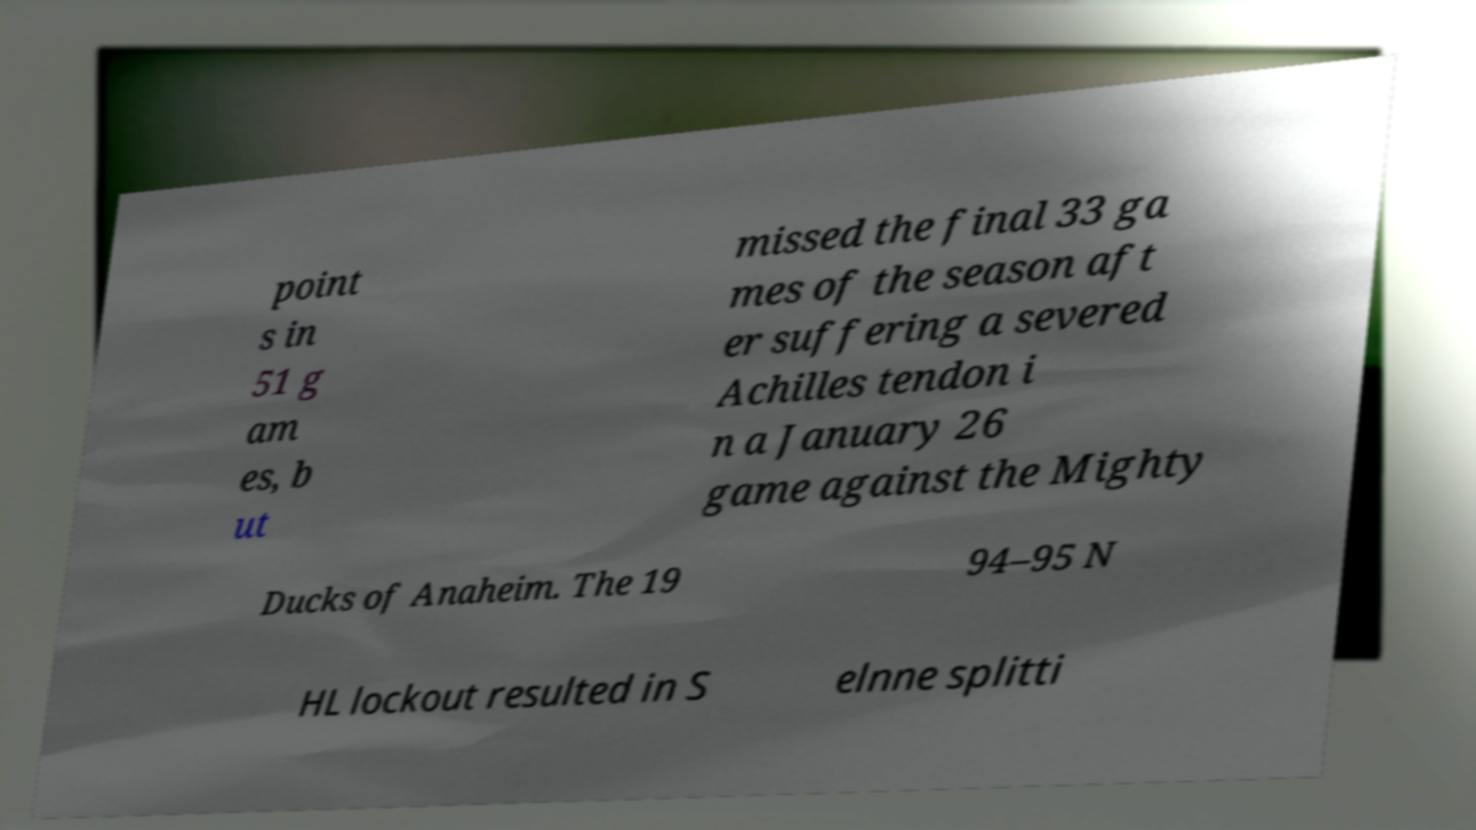Could you extract and type out the text from this image? point s in 51 g am es, b ut missed the final 33 ga mes of the season aft er suffering a severed Achilles tendon i n a January 26 game against the Mighty Ducks of Anaheim. The 19 94–95 N HL lockout resulted in S elnne splitti 